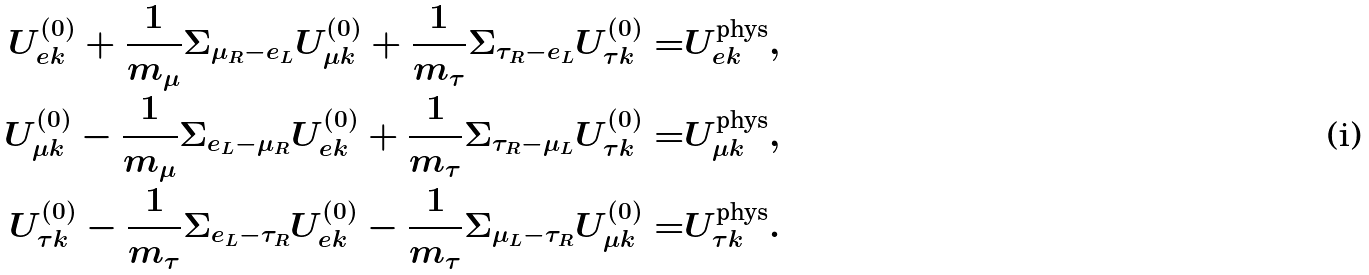Convert formula to latex. <formula><loc_0><loc_0><loc_500><loc_500>U _ { e k } ^ { ( 0 ) } + \frac { 1 } { m _ { \mu } } \Sigma _ { \mu _ { R } - e _ { L } } U _ { \mu k } ^ { ( 0 ) } + \frac { 1 } { m _ { \tau } } \Sigma _ { \tau _ { R } - e _ { L } } U _ { \tau k } ^ { ( 0 ) } = & U _ { e k } ^ { \text {phys} } , \\ U _ { \mu k } ^ { ( 0 ) } - \frac { 1 } { m _ { \mu } } \Sigma _ { e _ { L } - \mu _ { R } } U _ { e k } ^ { ( 0 ) } + \frac { 1 } { m _ { \tau } } \Sigma _ { \tau _ { R } - \mu _ { L } } U _ { \tau k } ^ { ( 0 ) } = & U _ { \mu k } ^ { \text {phys} } , \\ U _ { \tau k } ^ { ( 0 ) } - \frac { 1 } { m _ { \tau } } \Sigma _ { e _ { L } - \tau _ { R } } U _ { e k } ^ { ( 0 ) } - \frac { 1 } { m _ { \tau } } \Sigma _ { \mu _ { L } - \tau _ { R } } U _ { \mu k } ^ { ( 0 ) } = & U _ { \tau k } ^ { \text {phys} } .</formula> 